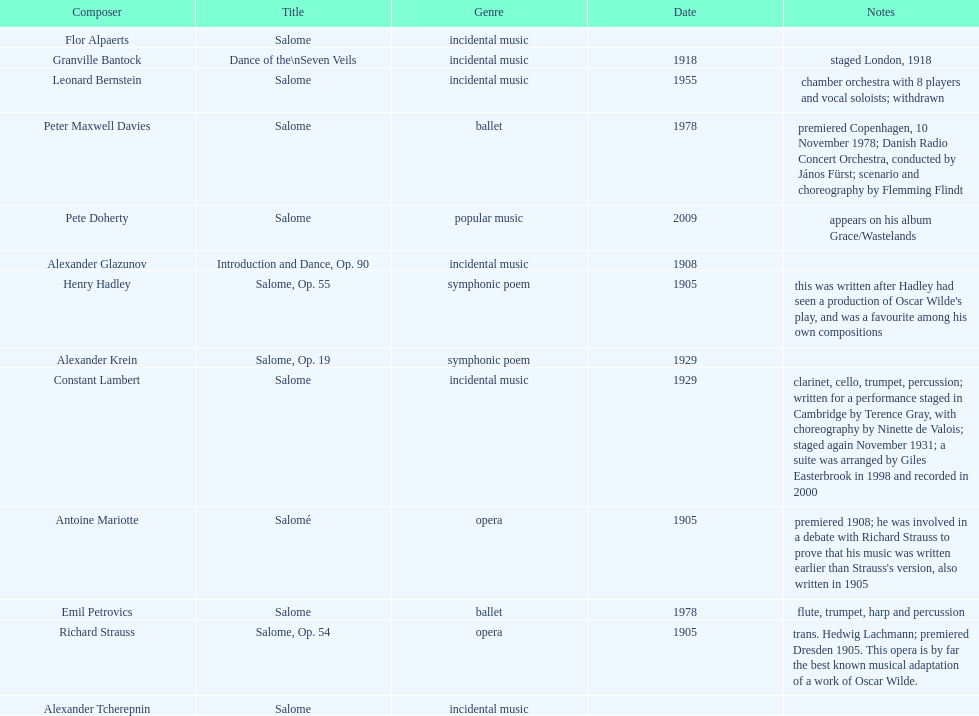What is the count of works entitled "salome?" 11. 